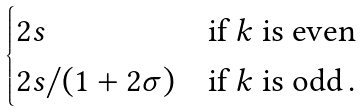<formula> <loc_0><loc_0><loc_500><loc_500>\begin{cases} 2 s & \text {if $k$ is even} \\ 2 s / ( 1 + 2 \sigma ) & \text {if $k$ is odd} \, . \end{cases}</formula> 